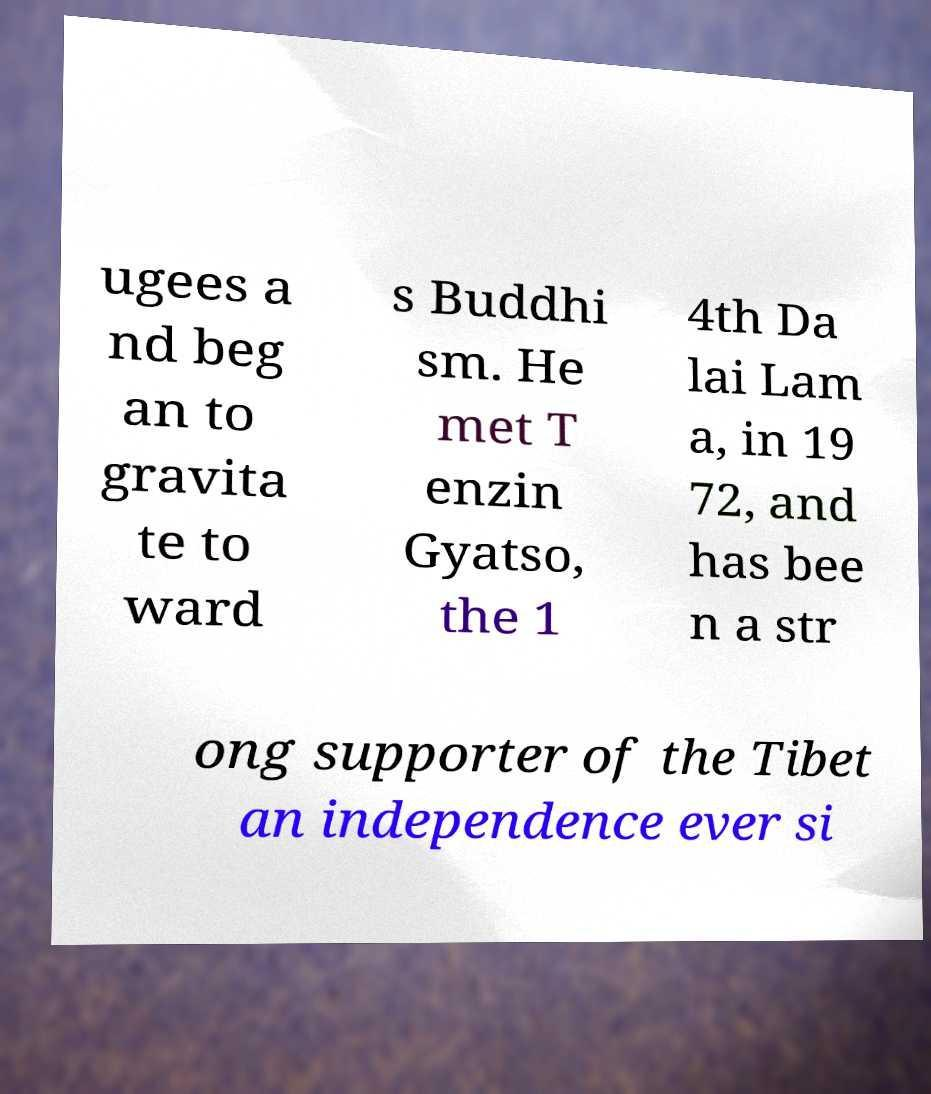There's text embedded in this image that I need extracted. Can you transcribe it verbatim? ugees a nd beg an to gravita te to ward s Buddhi sm. He met T enzin Gyatso, the 1 4th Da lai Lam a, in 19 72, and has bee n a str ong supporter of the Tibet an independence ever si 